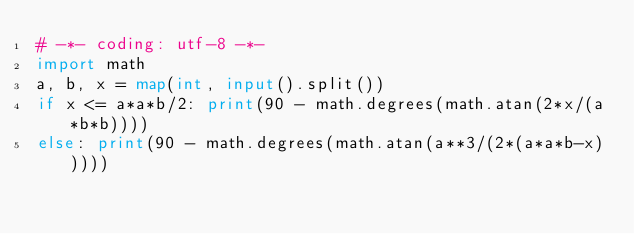Convert code to text. <code><loc_0><loc_0><loc_500><loc_500><_Python_># -*- coding: utf-8 -*-
import math
a, b, x = map(int, input().split())
if x <= a*a*b/2: print(90 - math.degrees(math.atan(2*x/(a*b*b))))
else: print(90 - math.degrees(math.atan(a**3/(2*(a*a*b-x)))))</code> 